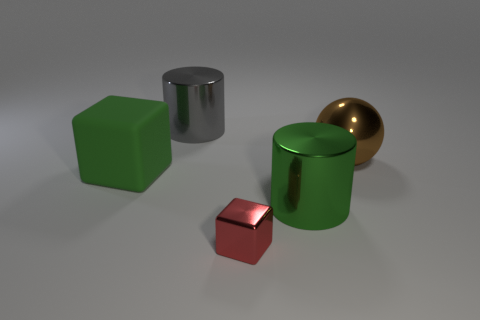There is another tiny object that is the same shape as the matte object; what is its material?
Keep it short and to the point. Metal. What color is the rubber object that is the same size as the brown ball?
Offer a very short reply. Green. Is the number of big metal objects that are behind the big brown metal sphere the same as the number of big green matte things?
Give a very brief answer. Yes. What color is the thing that is in front of the cylinder in front of the brown sphere?
Ensure brevity in your answer.  Red. There is a block behind the large cylinder that is in front of the big matte cube; what size is it?
Give a very brief answer. Large. What size is the metal thing that is the same color as the matte object?
Offer a very short reply. Large. What number of other objects are the same size as the red object?
Offer a very short reply. 0. The big cylinder that is right of the large metal cylinder that is left of the large green thing that is to the right of the rubber cube is what color?
Your response must be concise. Green. How many other objects are there of the same shape as the big gray thing?
Make the answer very short. 1. There is a object behind the brown shiny ball; what shape is it?
Keep it short and to the point. Cylinder. 